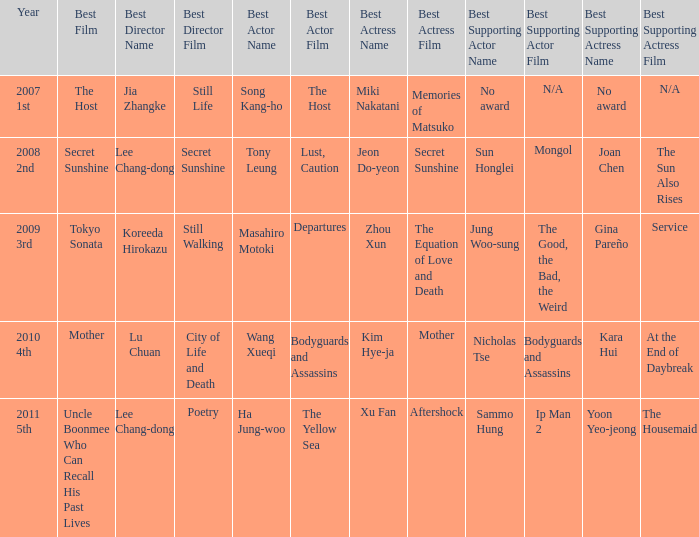Name the best supporting actress for sun honglei for mongol Joan Chen for The Sun Also Rises. 